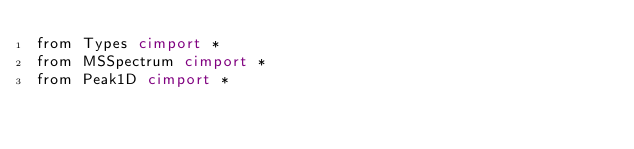Convert code to text. <code><loc_0><loc_0><loc_500><loc_500><_Cython_>from Types cimport *
from MSSpectrum cimport *
from Peak1D cimport *</code> 